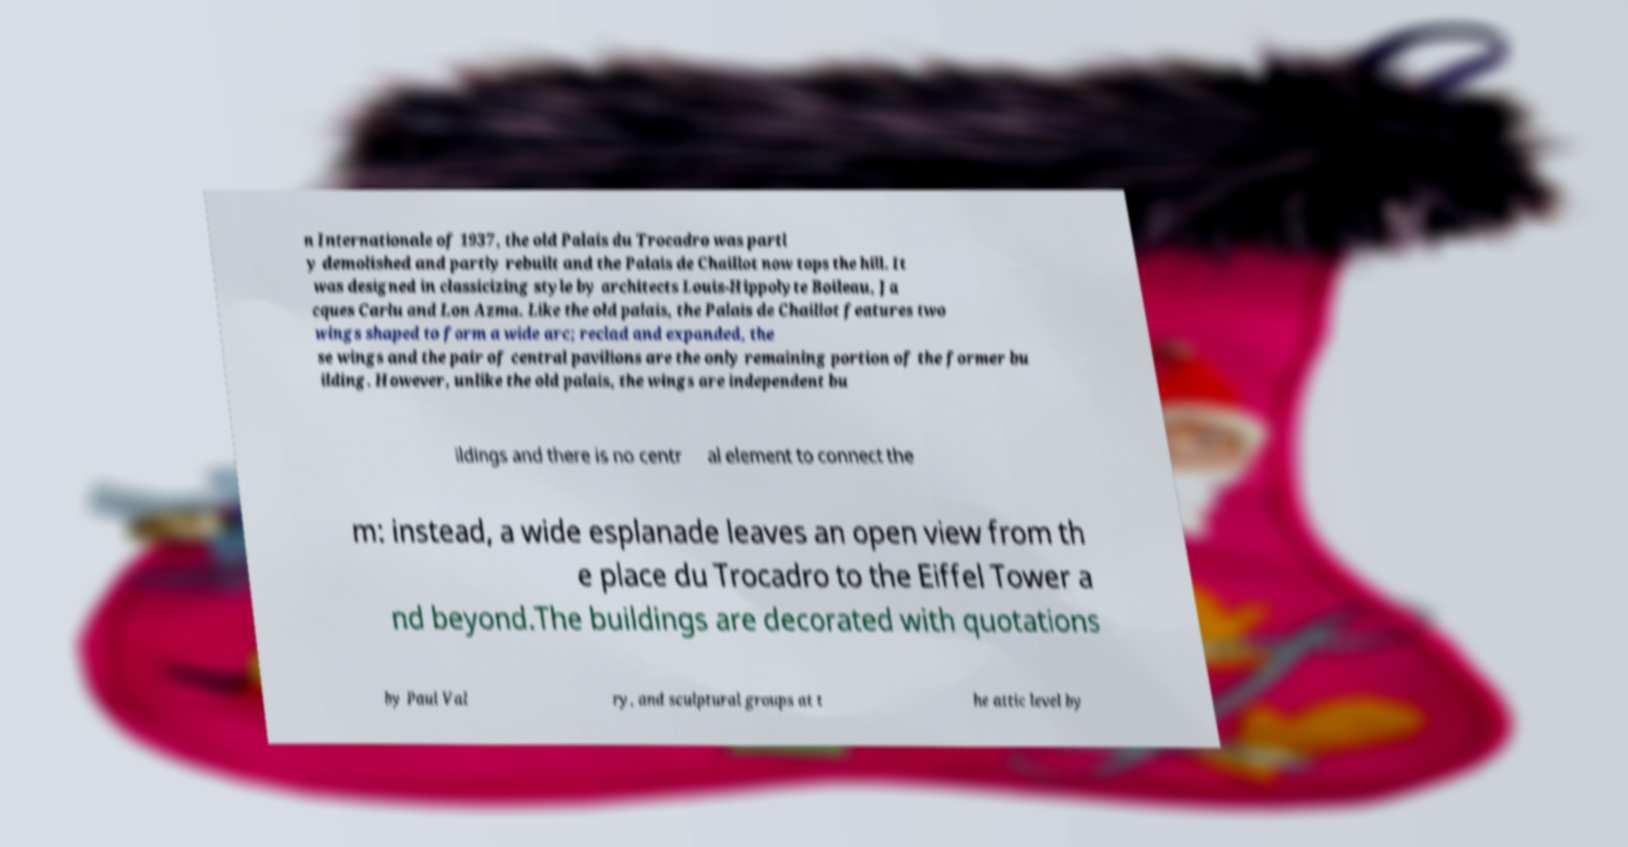Can you read and provide the text displayed in the image?This photo seems to have some interesting text. Can you extract and type it out for me? n Internationale of 1937, the old Palais du Trocadro was partl y demolished and partly rebuilt and the Palais de Chaillot now tops the hill. It was designed in classicizing style by architects Louis-Hippolyte Boileau, Ja cques Carlu and Lon Azma. Like the old palais, the Palais de Chaillot features two wings shaped to form a wide arc; reclad and expanded, the se wings and the pair of central pavilions are the only remaining portion of the former bu ilding. However, unlike the old palais, the wings are independent bu ildings and there is no centr al element to connect the m: instead, a wide esplanade leaves an open view from th e place du Trocadro to the Eiffel Tower a nd beyond.The buildings are decorated with quotations by Paul Val ry, and sculptural groups at t he attic level by 